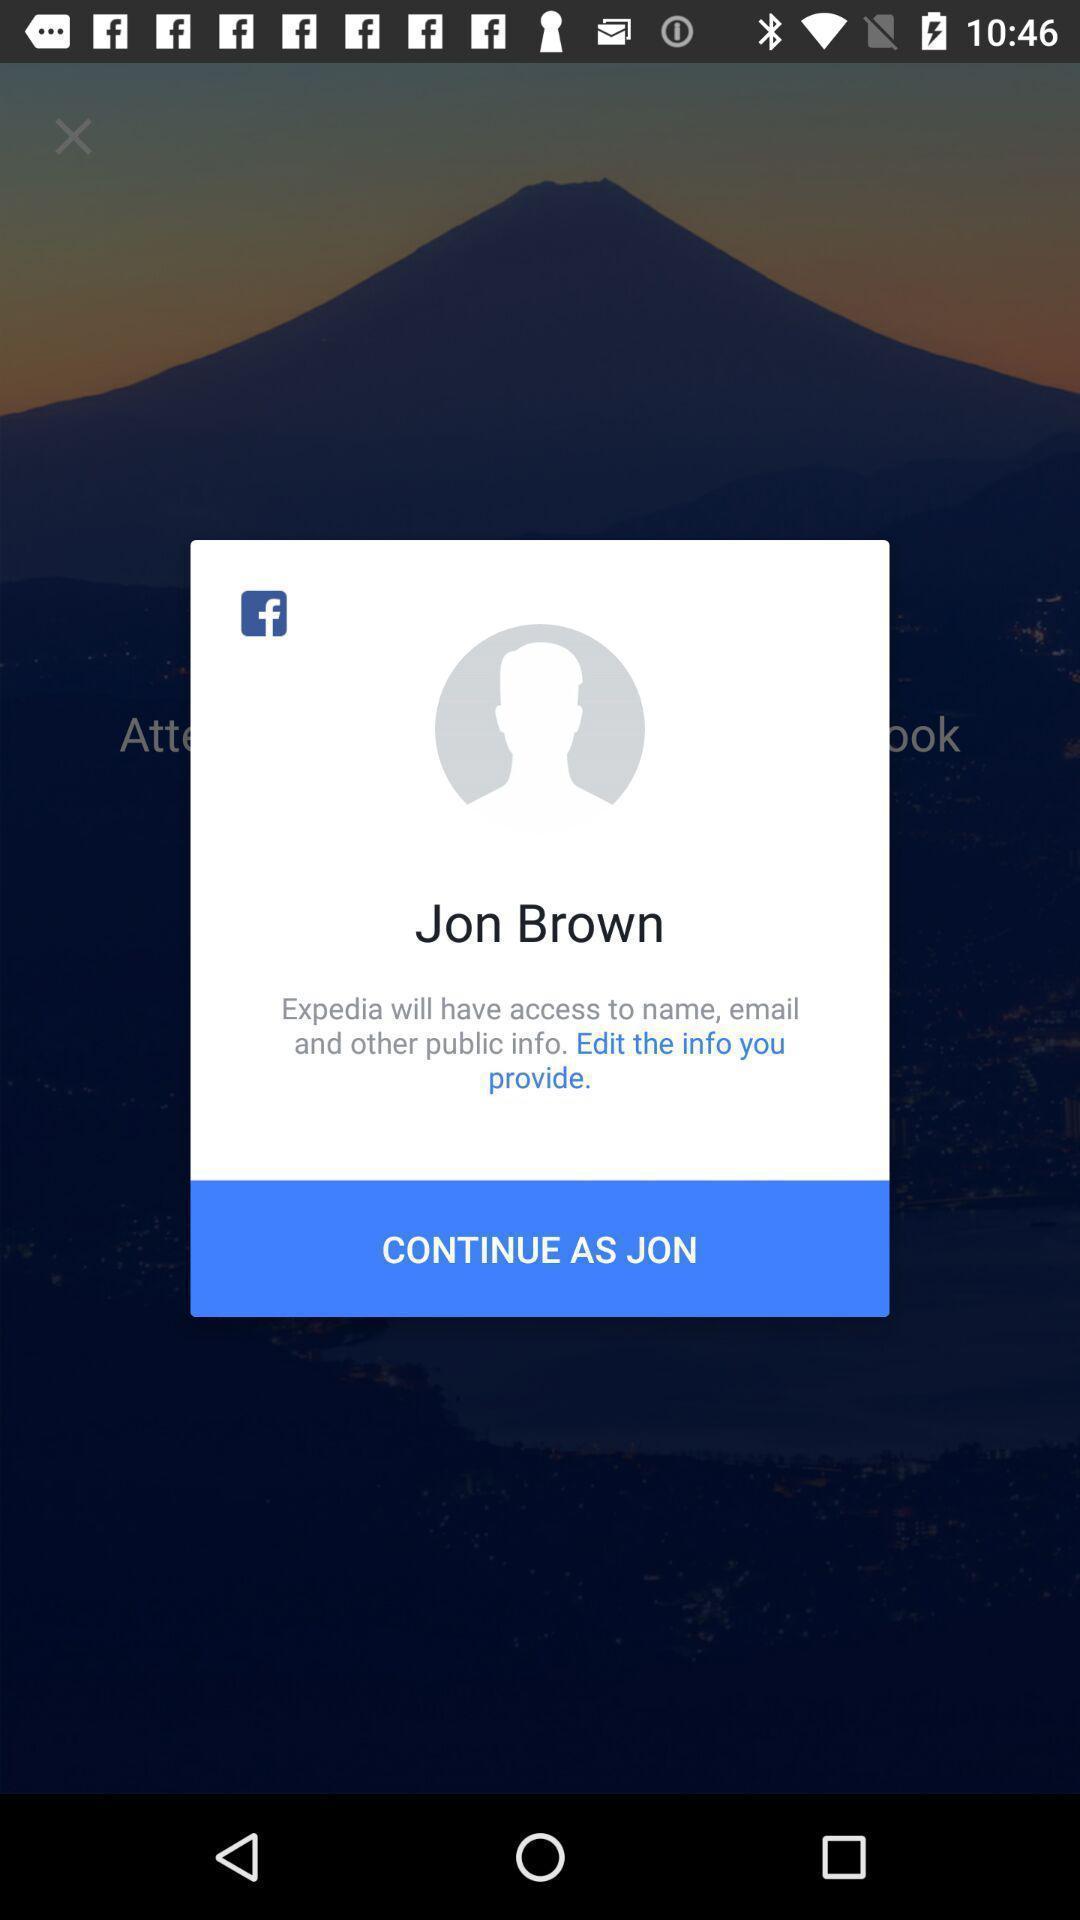Tell me about the visual elements in this screen capture. Sign in page. 